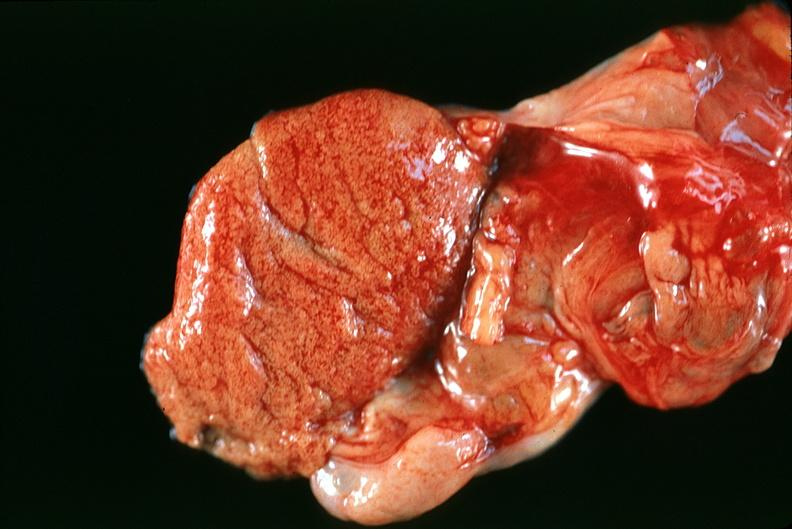what does this image show?
Answer the question using a single word or phrase. Normal testes 